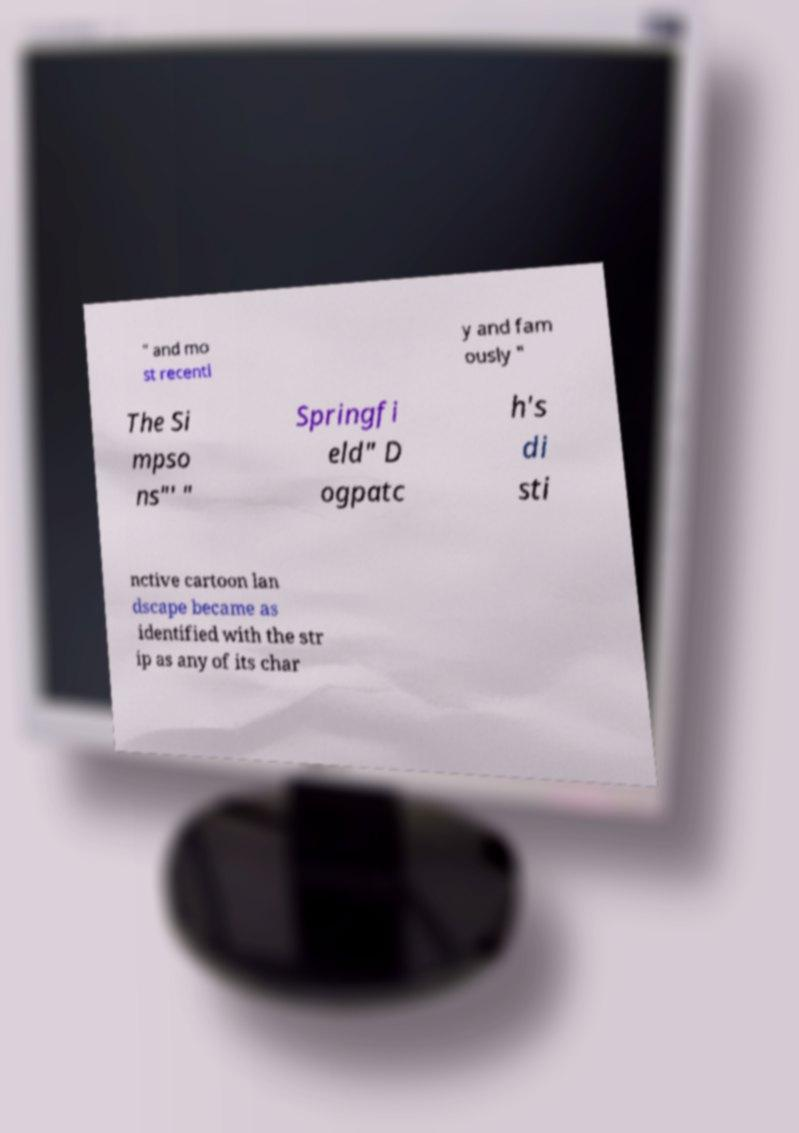Could you extract and type out the text from this image? " and mo st recentl y and fam ously " The Si mpso ns"' " Springfi eld" D ogpatc h's di sti nctive cartoon lan dscape became as identified with the str ip as any of its char 